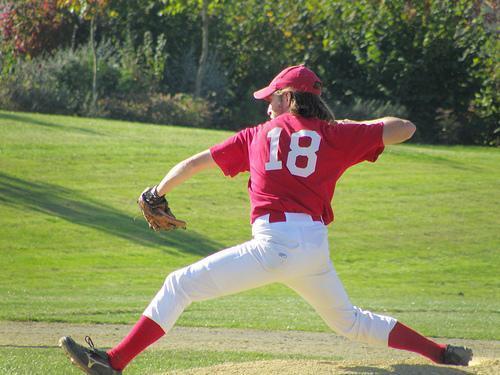How many pitchers are there?
Give a very brief answer. 1. 